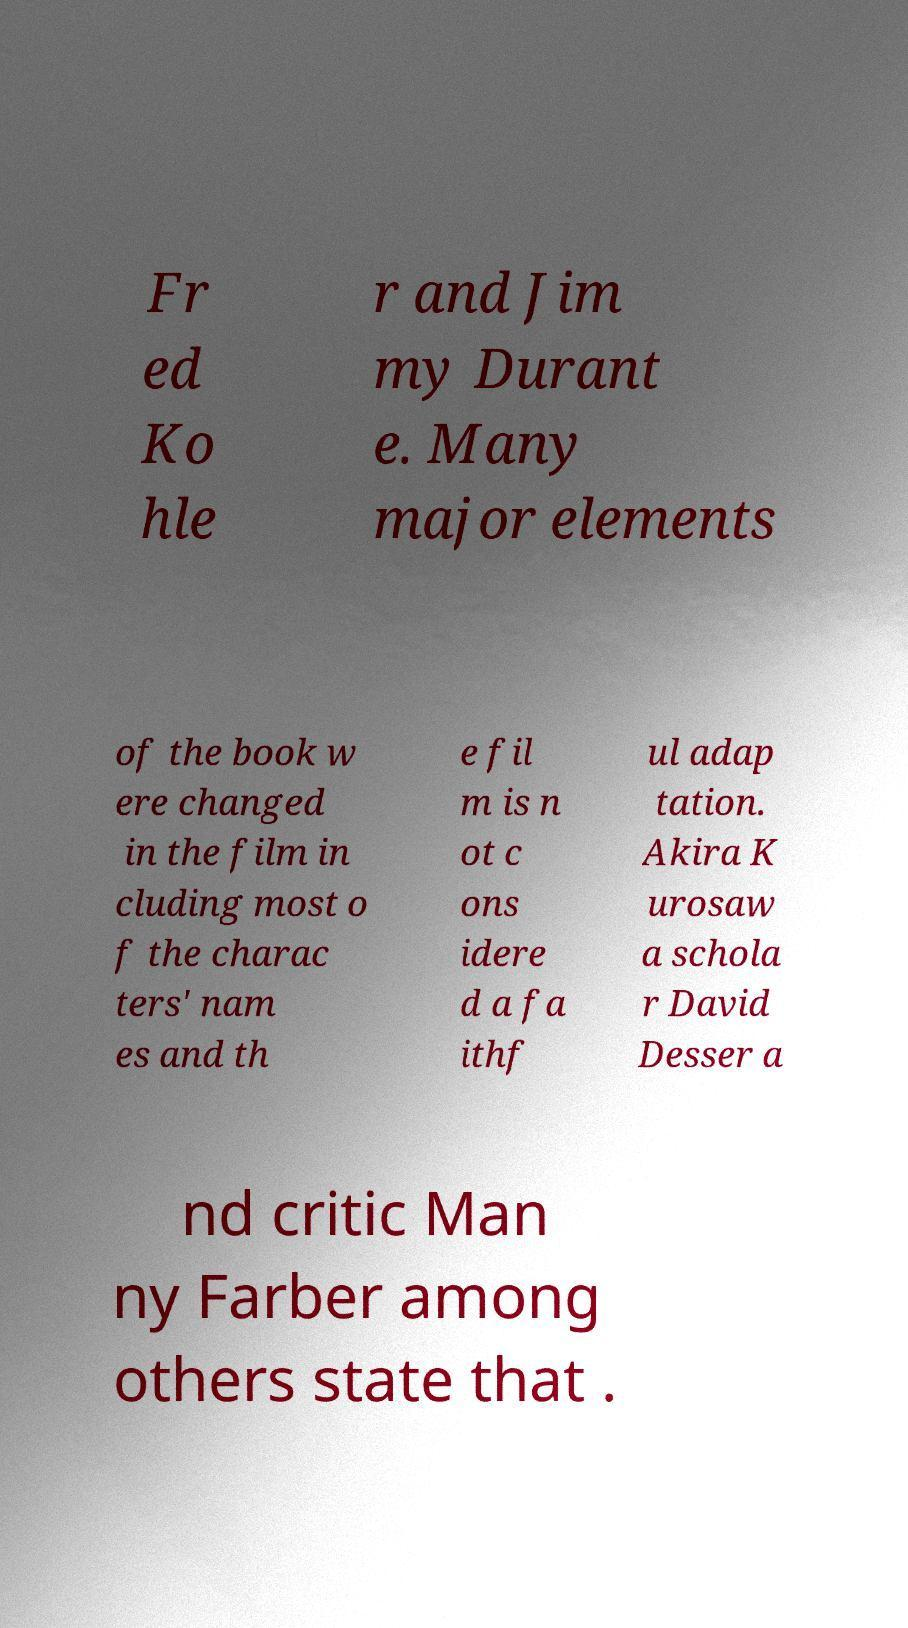Could you assist in decoding the text presented in this image and type it out clearly? Fr ed Ko hle r and Jim my Durant e. Many major elements of the book w ere changed in the film in cluding most o f the charac ters' nam es and th e fil m is n ot c ons idere d a fa ithf ul adap tation. Akira K urosaw a schola r David Desser a nd critic Man ny Farber among others state that . 